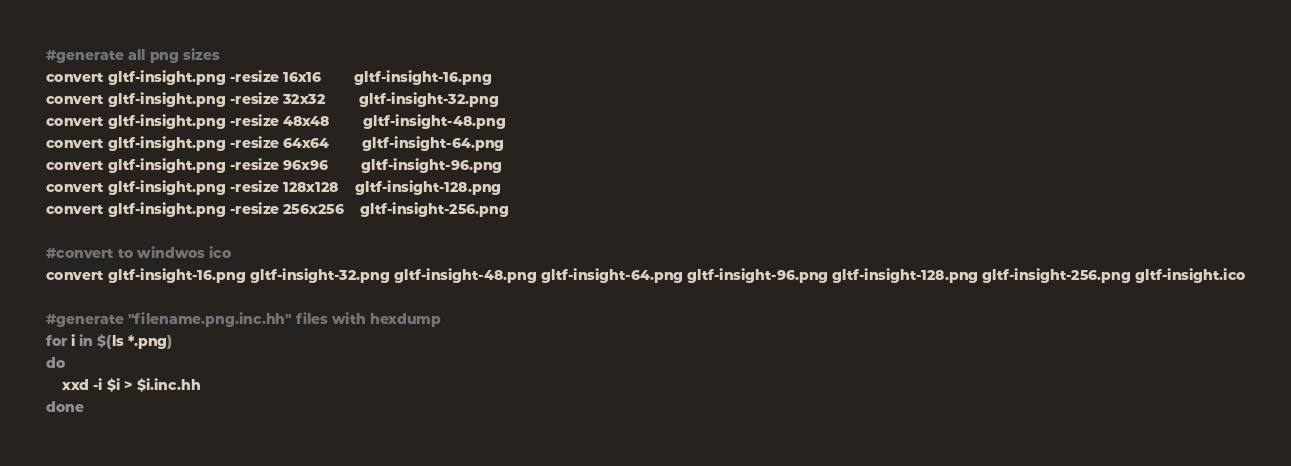<code> <loc_0><loc_0><loc_500><loc_500><_Bash_>
#generate all png sizes
convert gltf-insight.png -resize 16x16 		gltf-insight-16.png
convert gltf-insight.png -resize 32x32 		gltf-insight-32.png
convert gltf-insight.png -resize 48x48 		gltf-insight-48.png
convert gltf-insight.png -resize 64x64 		gltf-insight-64.png
convert gltf-insight.png -resize 96x96 		gltf-insight-96.png
convert gltf-insight.png -resize 128x128 	gltf-insight-128.png
convert gltf-insight.png -resize 256x256 	gltf-insight-256.png

#convert to windwos ico
convert gltf-insight-16.png gltf-insight-32.png gltf-insight-48.png gltf-insight-64.png gltf-insight-96.png gltf-insight-128.png gltf-insight-256.png gltf-insight.ico

#generate "filename.png.inc.hh" files with hexdump
for i in $(ls *.png)
do
	xxd -i $i > $i.inc.hh
done

</code> 